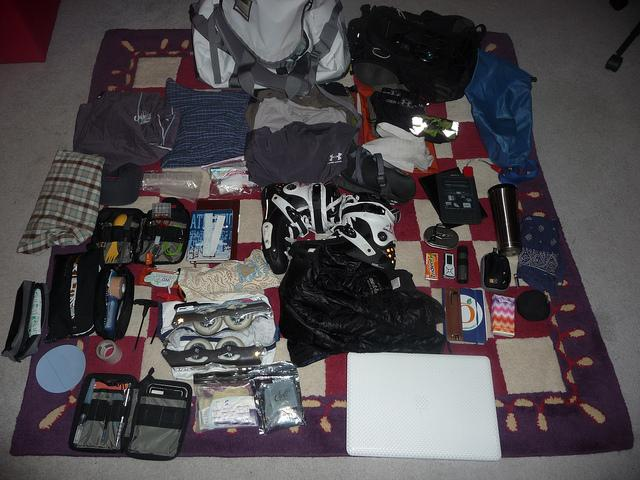Items here are laid out due to what purpose? display 